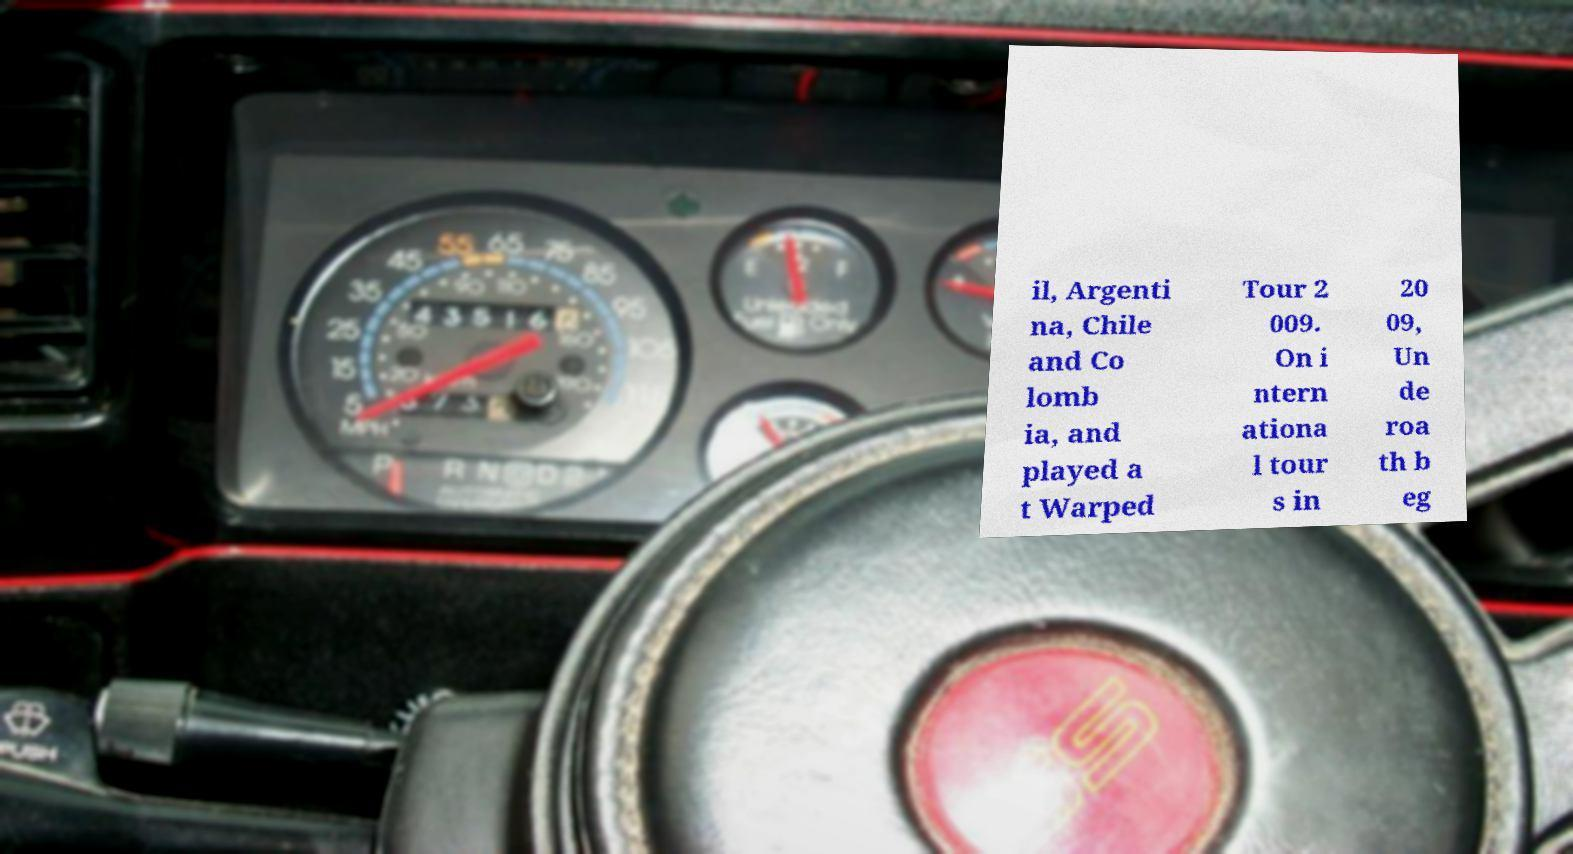Can you accurately transcribe the text from the provided image for me? il, Argenti na, Chile and Co lomb ia, and played a t Warped Tour 2 009. On i ntern ationa l tour s in 20 09, Un de roa th b eg 